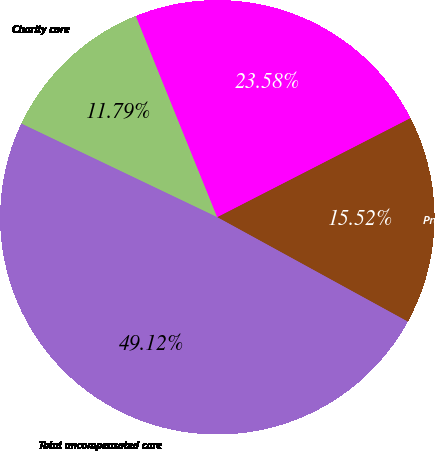Convert chart. <chart><loc_0><loc_0><loc_500><loc_500><pie_chart><fcel>Charity care<fcel>Uninsured discounts<fcel>Provision for doubtful<fcel>Total uncompensated care<nl><fcel>11.79%<fcel>23.58%<fcel>15.52%<fcel>49.12%<nl></chart> 